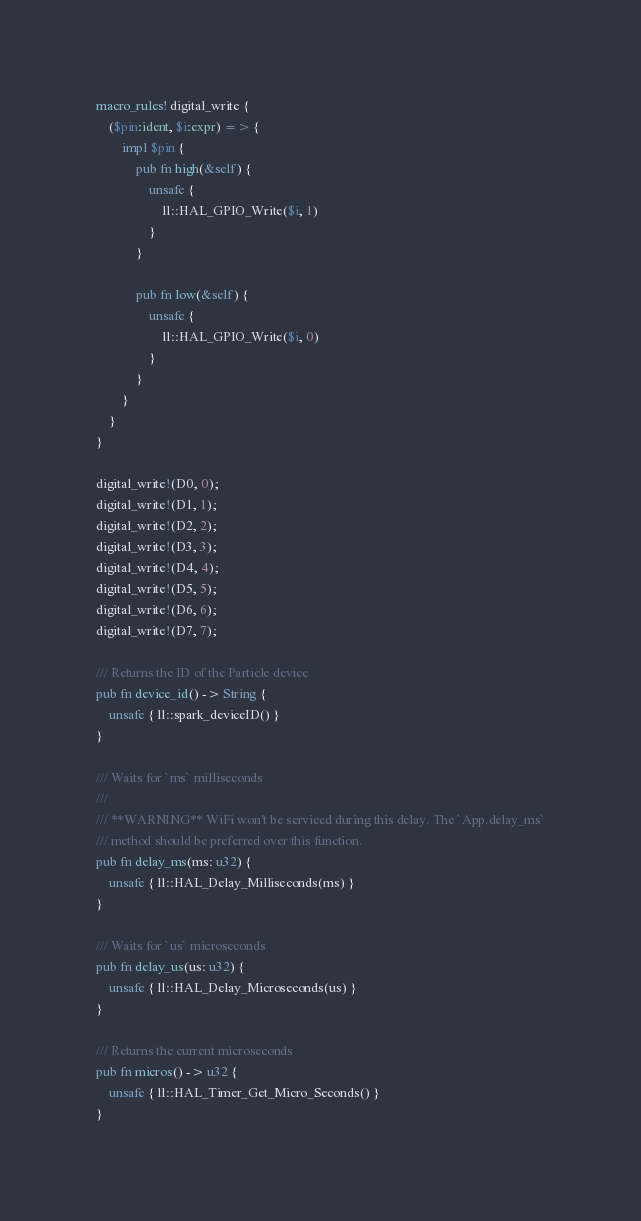Convert code to text. <code><loc_0><loc_0><loc_500><loc_500><_Rust_>
macro_rules! digital_write {
    ($pin:ident, $i:expr) => {
        impl $pin {
            pub fn high(&self) {
                unsafe {
                    ll::HAL_GPIO_Write($i, 1)
                }
            }

            pub fn low(&self) {
                unsafe {
                    ll::HAL_GPIO_Write($i, 0)
                }
            }
        }
    }
}

digital_write!(D0, 0);
digital_write!(D1, 1);
digital_write!(D2, 2);
digital_write!(D3, 3);
digital_write!(D4, 4);
digital_write!(D5, 5);
digital_write!(D6, 6);
digital_write!(D7, 7);

/// Returns the ID of the Particle device
pub fn device_id() -> String {
    unsafe { ll::spark_deviceID() }
}

/// Waits for `ms` milliseconds
///
/// **WARNING** WiFi won't be serviced during this delay. The `App.delay_ms`
/// method should be preferred over this function.
pub fn delay_ms(ms: u32) {
    unsafe { ll::HAL_Delay_Milliseconds(ms) }
}

/// Waits for `us` microseconds
pub fn delay_us(us: u32) {
    unsafe { ll::HAL_Delay_Microseconds(us) }
}

/// Returns the current microseconds
pub fn micros() -> u32 {
    unsafe { ll::HAL_Timer_Get_Micro_Seconds() }
}
</code> 